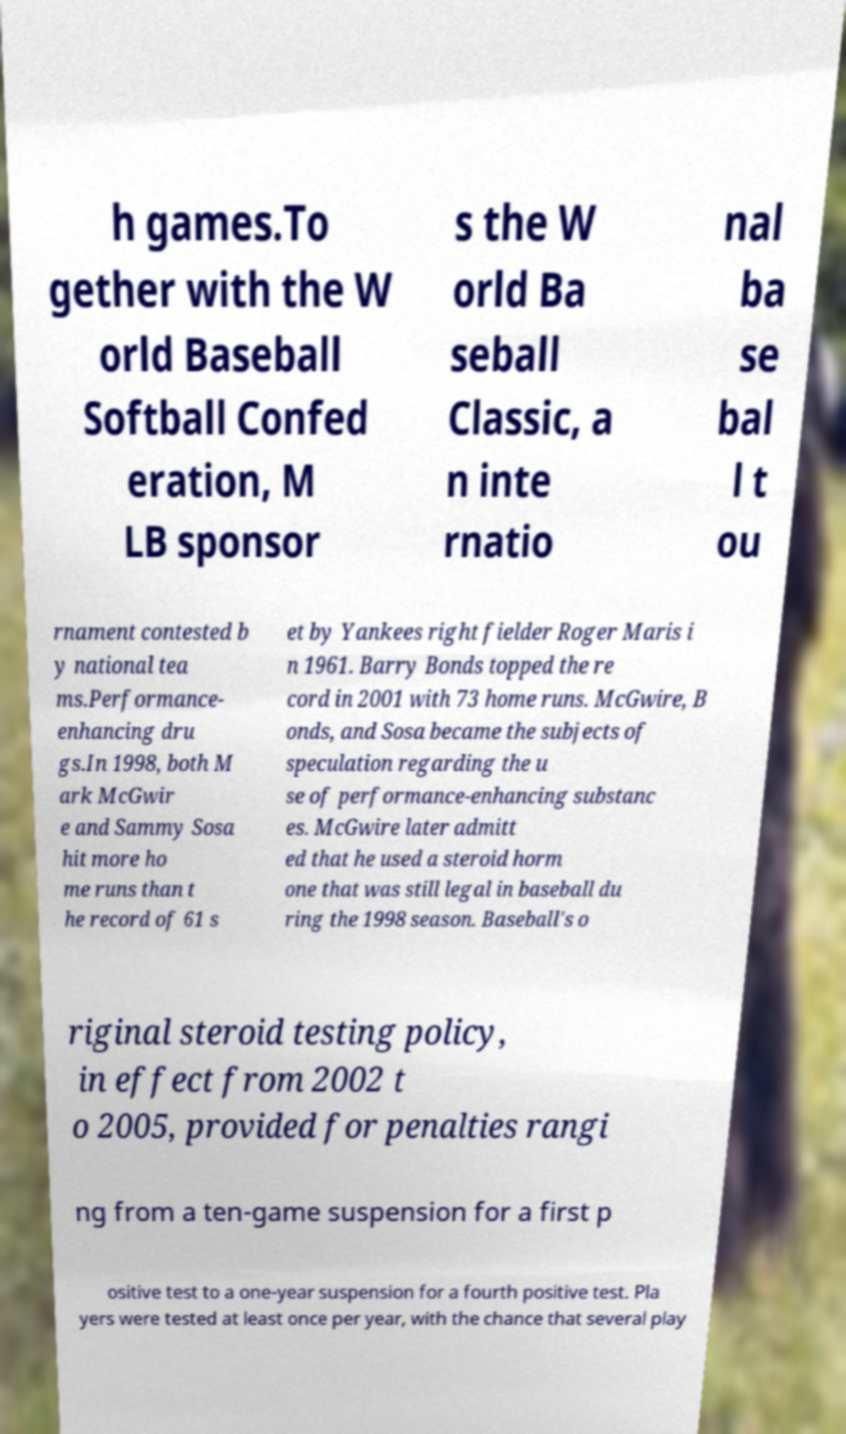There's text embedded in this image that I need extracted. Can you transcribe it verbatim? h games.To gether with the W orld Baseball Softball Confed eration, M LB sponsor s the W orld Ba seball Classic, a n inte rnatio nal ba se bal l t ou rnament contested b y national tea ms.Performance- enhancing dru gs.In 1998, both M ark McGwir e and Sammy Sosa hit more ho me runs than t he record of 61 s et by Yankees right fielder Roger Maris i n 1961. Barry Bonds topped the re cord in 2001 with 73 home runs. McGwire, B onds, and Sosa became the subjects of speculation regarding the u se of performance-enhancing substanc es. McGwire later admitt ed that he used a steroid horm one that was still legal in baseball du ring the 1998 season. Baseball's o riginal steroid testing policy, in effect from 2002 t o 2005, provided for penalties rangi ng from a ten-game suspension for a first p ositive test to a one-year suspension for a fourth positive test. Pla yers were tested at least once per year, with the chance that several play 